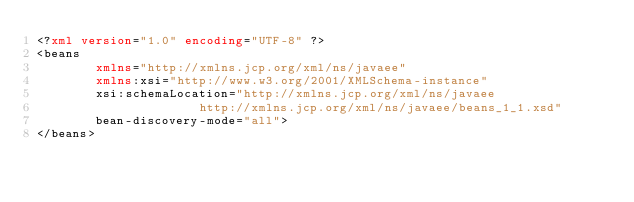<code> <loc_0><loc_0><loc_500><loc_500><_XML_><?xml version="1.0" encoding="UTF-8" ?>
<beans
        xmlns="http://xmlns.jcp.org/xml/ns/javaee"
        xmlns:xsi="http://www.w3.org/2001/XMLSchema-instance"
        xsi:schemaLocation="http://xmlns.jcp.org/xml/ns/javaee
                      http://xmlns.jcp.org/xml/ns/javaee/beans_1_1.xsd"
        bean-discovery-mode="all">
</beans></code> 